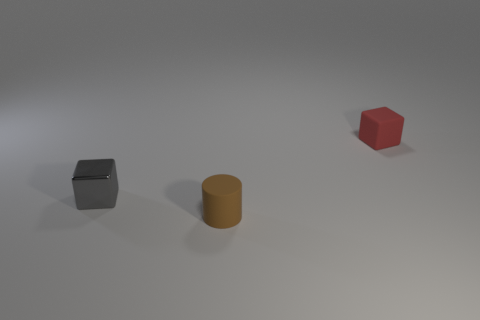How many tiny things are both behind the cylinder and left of the red block?
Keep it short and to the point. 1. What color is the metal thing?
Offer a very short reply. Gray. Is there a tiny cube made of the same material as the brown object?
Provide a short and direct response. Yes. There is a tiny rubber thing in front of the block in front of the small red rubber block; are there any tiny cylinders that are to the left of it?
Offer a terse response. No. There is a small brown object; are there any rubber objects right of it?
Your response must be concise. Yes. Are there any tiny rubber objects of the same color as the cylinder?
Your response must be concise. No. How many small things are either brown objects or matte cubes?
Make the answer very short. 2. Is the material of the small block in front of the tiny red rubber thing the same as the small brown cylinder?
Keep it short and to the point. No. What shape is the matte object that is behind the cube in front of the rubber thing behind the brown rubber thing?
Your answer should be compact. Cube. What number of gray things are cubes or tiny cylinders?
Offer a terse response. 1. 